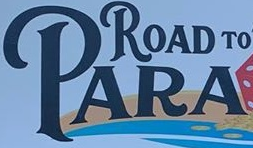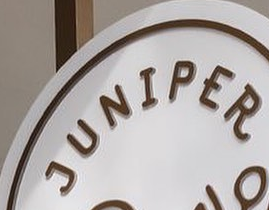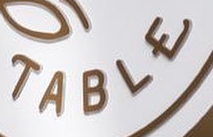What text appears in these images from left to right, separated by a semicolon? PARA; JUNIPER; TABLE 